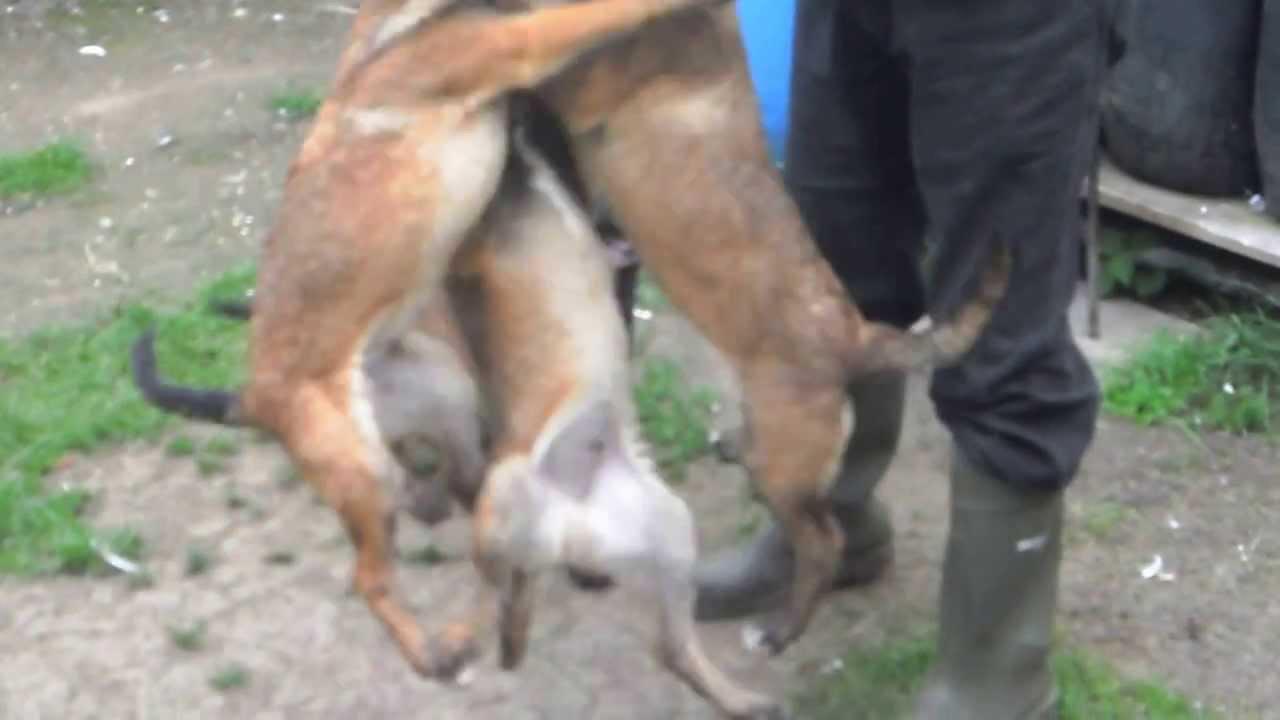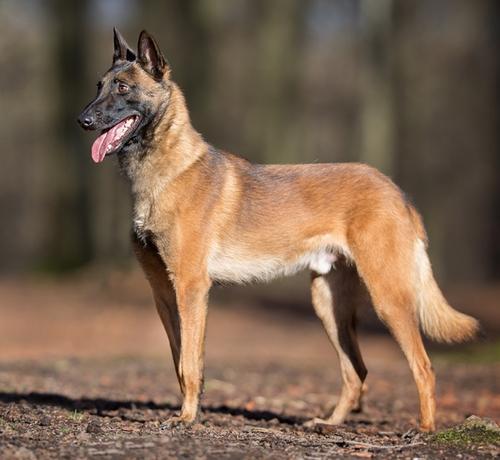The first image is the image on the left, the second image is the image on the right. For the images shown, is this caption "One dog is looking up." true? Answer yes or no. No. The first image is the image on the left, the second image is the image on the right. Considering the images on both sides, is "In at least one image the dog is not looking toward the camera." valid? Answer yes or no. Yes. 